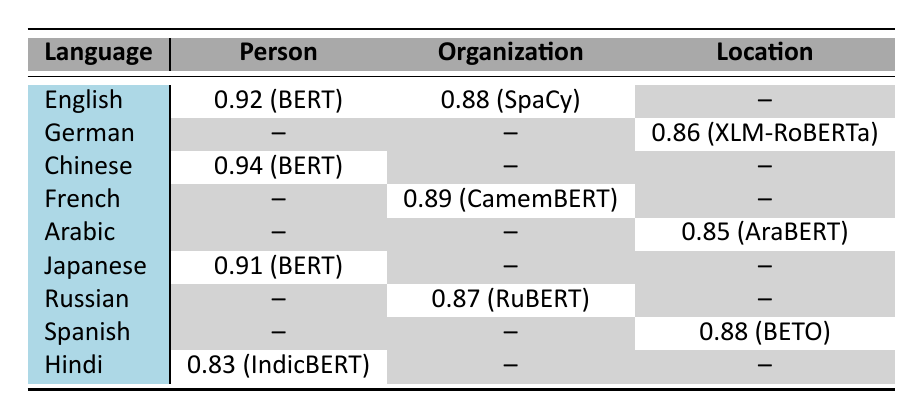What is the accuracy of the NER system for Person entities in English? The table shows the accuracy for Person entities in English is 0.92 with the NER system BERT.
Answer: 0.92 Which language has the highest accuracy for Organization entities? Upon inspecting the table, French has the highest accuracy for Organization entities with a score of 0.89 using the CamemBERT NER system.
Answer: French, 0.89 Is there any NER system listed for the Location entity type in German? The table indicates that there is an NER system available for the Location entity type in German, where XLM-RoBERTa has an accuracy of 0.86.
Answer: Yes What is the average accuracy of the NER systems for Person entities across all languages presented? Analyzing the Person entity accuracies: English (0.92), Chinese (0.94), Japanese (0.91), and Hindi (0.83), we sum up these values (0.92 + 0.94 + 0.91 + 0.83 = 3.60) and divide by the number of entries (4), resulting in an average accuracy of 3.60 / 4 = 0.90.
Answer: 0.90 Which NER system has the lowest accuracy for Organization entities, and what is its value? After reviewing the table, the NER system with the lowest accuracy for Organization entities is RuBERT, which has an accuracy of 0.87.
Answer: RuBERT, 0.87 How many different languages have NER systems listed for Location entities? The table lists NER systems for Location entities in German (0.86), Arabic (0.85), and Spanish (0.88), which sums up to three different languages having these NER systems.
Answer: 3 Does the table show any NER system with a perfect score of 1.0? Upon reviewing the table, it can be seen that there is no NER system listed with a perfect accuracy score of 1.0.
Answer: No Which NER system has the highest accuracy for Person entities, and what is that accuracy? Examining the table, Chinese's NER system, BERT, has the highest accuracy for Person entities at 0.94.
Answer: BERT, 0.94 How does the accuracy of the SpaCy system for Organization entities compare to that of CamemBERT for the same entity type? The table shows that SpaCy has an accuracy of 0.88 for Organization entities while CamemBERT has a higher accuracy of 0.89.
Answer: CamemBERT is higher by 0.01 